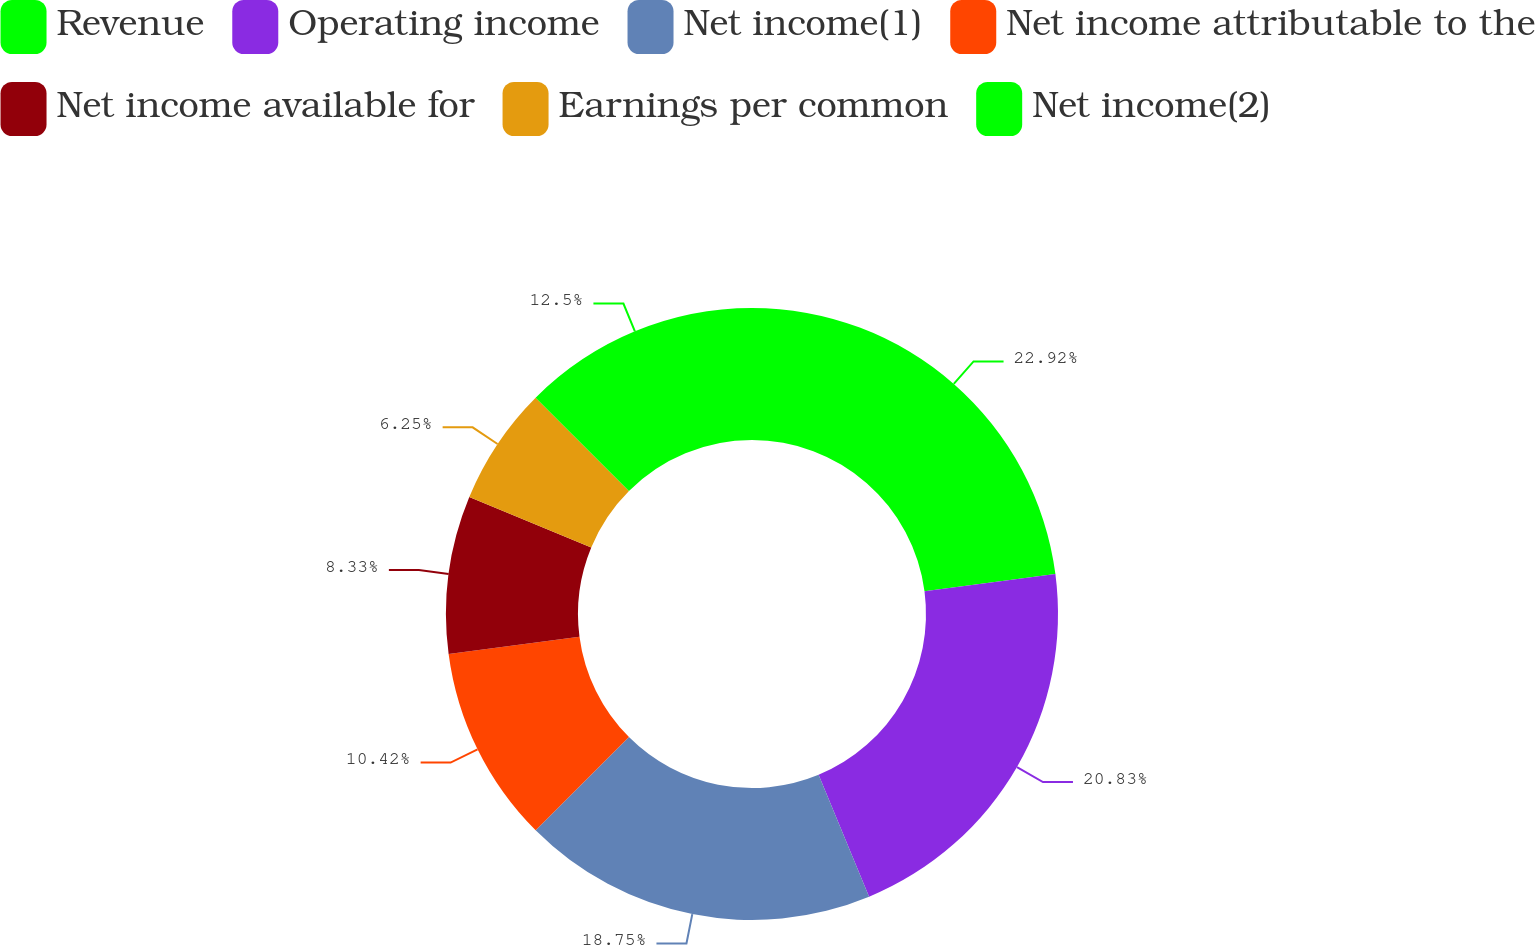<chart> <loc_0><loc_0><loc_500><loc_500><pie_chart><fcel>Revenue<fcel>Operating income<fcel>Net income(1)<fcel>Net income attributable to the<fcel>Net income available for<fcel>Earnings per common<fcel>Net income(2)<nl><fcel>22.92%<fcel>20.83%<fcel>18.75%<fcel>10.42%<fcel>8.33%<fcel>6.25%<fcel>12.5%<nl></chart> 